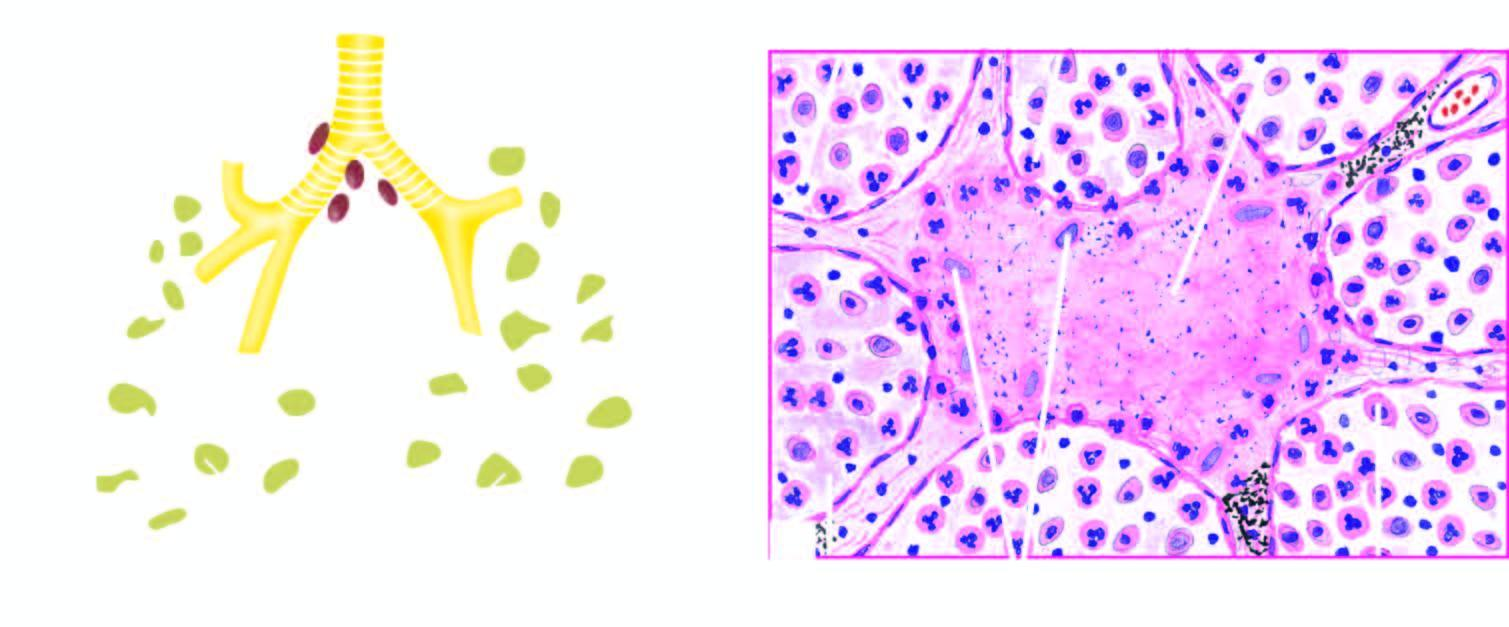do these cases have numerous acid-fast bacilli not shown here in afb staining?
Answer the question using a single word or phrase. Yes 